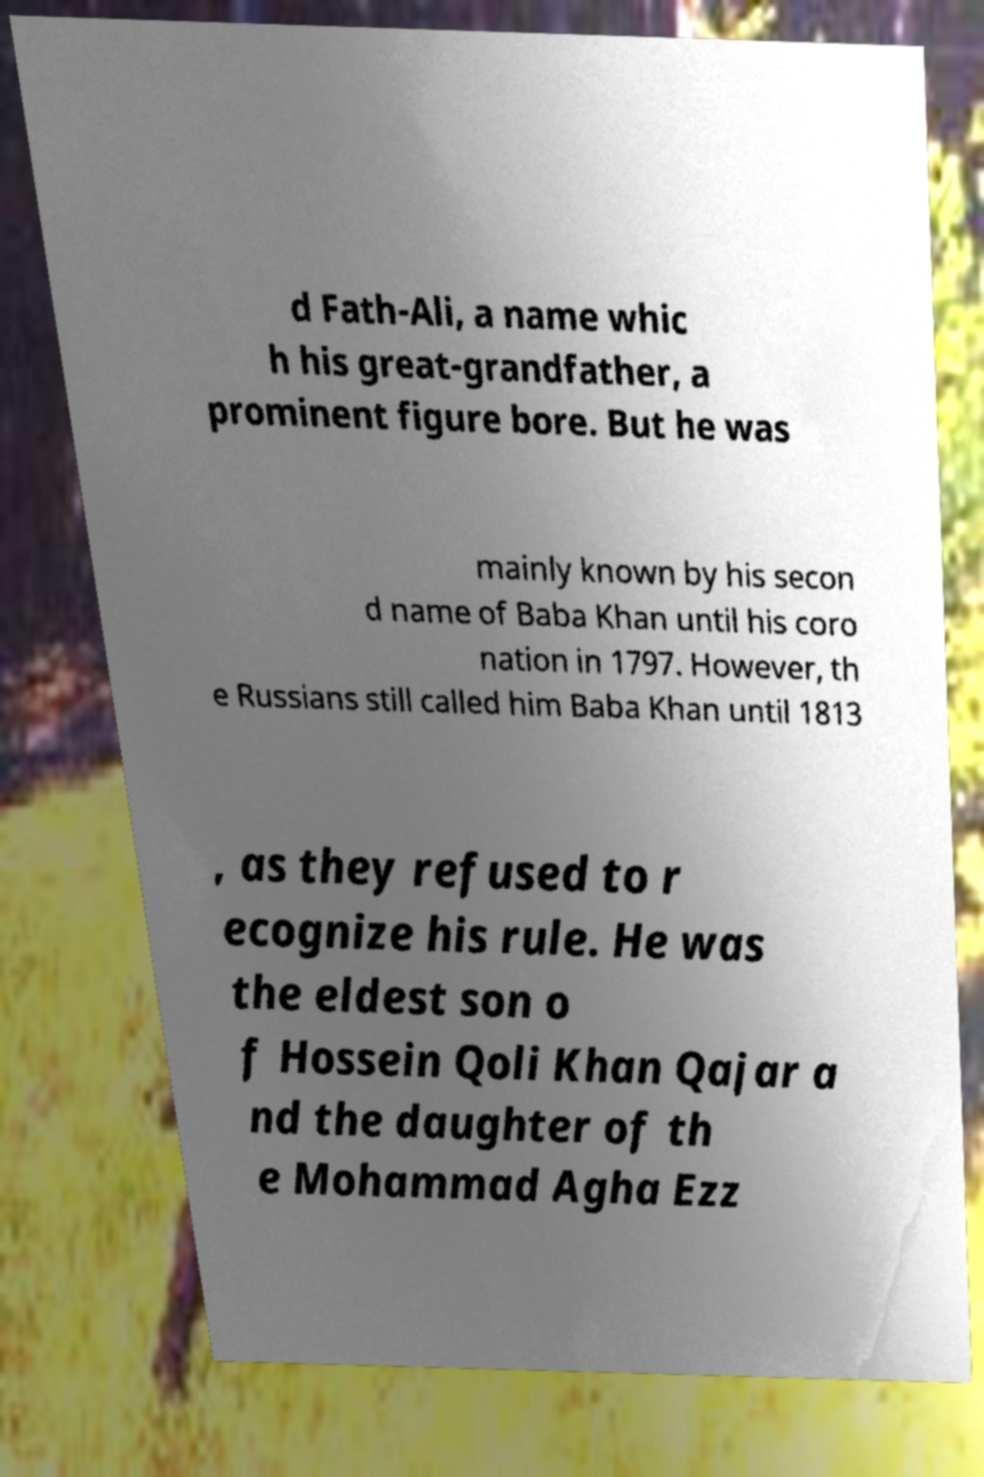Please identify and transcribe the text found in this image. d Fath-Ali, a name whic h his great-grandfather, a prominent figure bore. But he was mainly known by his secon d name of Baba Khan until his coro nation in 1797. However, th e Russians still called him Baba Khan until 1813 , as they refused to r ecognize his rule. He was the eldest son o f Hossein Qoli Khan Qajar a nd the daughter of th e Mohammad Agha Ezz 